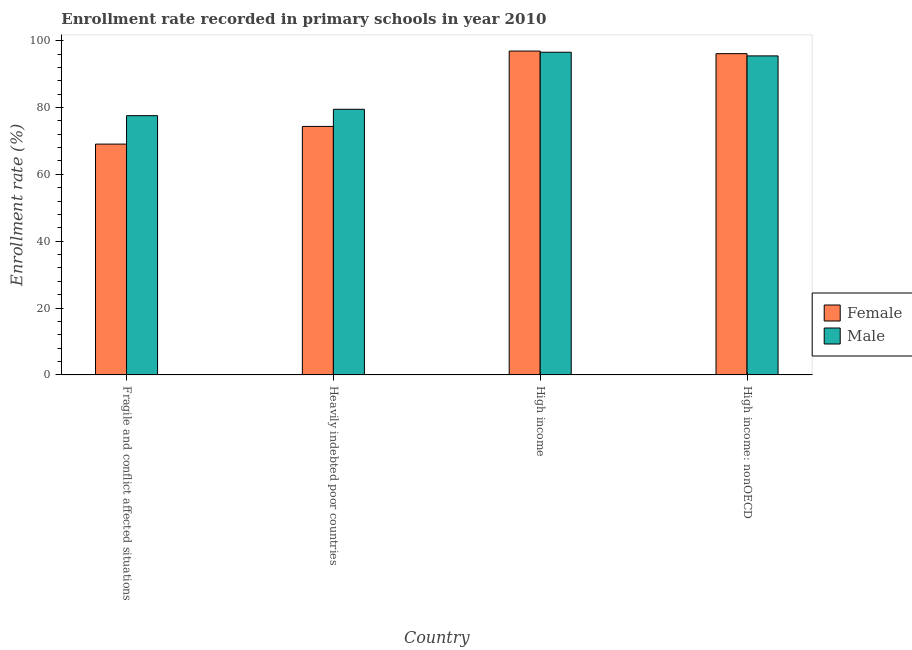How many different coloured bars are there?
Make the answer very short. 2. How many bars are there on the 2nd tick from the left?
Provide a short and direct response. 2. How many bars are there on the 1st tick from the right?
Give a very brief answer. 2. What is the label of the 4th group of bars from the left?
Provide a succinct answer. High income: nonOECD. What is the enrollment rate of female students in Fragile and conflict affected situations?
Your response must be concise. 69.05. Across all countries, what is the maximum enrollment rate of male students?
Make the answer very short. 96.54. Across all countries, what is the minimum enrollment rate of female students?
Provide a succinct answer. 69.05. In which country was the enrollment rate of male students maximum?
Provide a succinct answer. High income. In which country was the enrollment rate of female students minimum?
Your answer should be compact. Fragile and conflict affected situations. What is the total enrollment rate of male students in the graph?
Provide a succinct answer. 349. What is the difference between the enrollment rate of female students in Fragile and conflict affected situations and that in High income: nonOECD?
Make the answer very short. -27.06. What is the difference between the enrollment rate of female students in Heavily indebted poor countries and the enrollment rate of male students in Fragile and conflict affected situations?
Ensure brevity in your answer.  -3.22. What is the average enrollment rate of female students per country?
Keep it short and to the point. 84.1. What is the difference between the enrollment rate of female students and enrollment rate of male students in Heavily indebted poor countries?
Provide a short and direct response. -5.12. What is the ratio of the enrollment rate of male students in Heavily indebted poor countries to that in High income: nonOECD?
Provide a succinct answer. 0.83. Is the enrollment rate of male students in Fragile and conflict affected situations less than that in High income: nonOECD?
Provide a short and direct response. Yes. Is the difference between the enrollment rate of male students in Heavily indebted poor countries and High income greater than the difference between the enrollment rate of female students in Heavily indebted poor countries and High income?
Make the answer very short. Yes. What is the difference between the highest and the second highest enrollment rate of male students?
Offer a very short reply. 1.1. What is the difference between the highest and the lowest enrollment rate of male students?
Ensure brevity in your answer.  18.98. What does the 1st bar from the left in Fragile and conflict affected situations represents?
Your answer should be very brief. Female. Are all the bars in the graph horizontal?
Offer a very short reply. No. Are the values on the major ticks of Y-axis written in scientific E-notation?
Make the answer very short. No. Does the graph contain grids?
Offer a very short reply. No. What is the title of the graph?
Your answer should be very brief. Enrollment rate recorded in primary schools in year 2010. Does "RDB nonconcessional" appear as one of the legend labels in the graph?
Your answer should be compact. No. What is the label or title of the Y-axis?
Offer a terse response. Enrollment rate (%). What is the Enrollment rate (%) of Female in Fragile and conflict affected situations?
Make the answer very short. 69.05. What is the Enrollment rate (%) in Male in Fragile and conflict affected situations?
Your answer should be very brief. 77.56. What is the Enrollment rate (%) in Female in Heavily indebted poor countries?
Keep it short and to the point. 74.34. What is the Enrollment rate (%) of Male in Heavily indebted poor countries?
Offer a very short reply. 79.46. What is the Enrollment rate (%) of Female in High income?
Provide a succinct answer. 96.88. What is the Enrollment rate (%) in Male in High income?
Your answer should be compact. 96.54. What is the Enrollment rate (%) of Female in High income: nonOECD?
Your answer should be compact. 96.11. What is the Enrollment rate (%) in Male in High income: nonOECD?
Keep it short and to the point. 95.44. Across all countries, what is the maximum Enrollment rate (%) in Female?
Your response must be concise. 96.88. Across all countries, what is the maximum Enrollment rate (%) of Male?
Keep it short and to the point. 96.54. Across all countries, what is the minimum Enrollment rate (%) of Female?
Offer a terse response. 69.05. Across all countries, what is the minimum Enrollment rate (%) of Male?
Your answer should be compact. 77.56. What is the total Enrollment rate (%) in Female in the graph?
Provide a succinct answer. 336.39. What is the total Enrollment rate (%) of Male in the graph?
Make the answer very short. 349. What is the difference between the Enrollment rate (%) of Female in Fragile and conflict affected situations and that in Heavily indebted poor countries?
Make the answer very short. -5.29. What is the difference between the Enrollment rate (%) of Male in Fragile and conflict affected situations and that in Heavily indebted poor countries?
Your response must be concise. -1.9. What is the difference between the Enrollment rate (%) of Female in Fragile and conflict affected situations and that in High income?
Your response must be concise. -27.83. What is the difference between the Enrollment rate (%) in Male in Fragile and conflict affected situations and that in High income?
Keep it short and to the point. -18.98. What is the difference between the Enrollment rate (%) of Female in Fragile and conflict affected situations and that in High income: nonOECD?
Offer a terse response. -27.06. What is the difference between the Enrollment rate (%) in Male in Fragile and conflict affected situations and that in High income: nonOECD?
Your answer should be compact. -17.88. What is the difference between the Enrollment rate (%) of Female in Heavily indebted poor countries and that in High income?
Offer a very short reply. -22.54. What is the difference between the Enrollment rate (%) in Male in Heavily indebted poor countries and that in High income?
Keep it short and to the point. -17.07. What is the difference between the Enrollment rate (%) of Female in Heavily indebted poor countries and that in High income: nonOECD?
Offer a terse response. -21.77. What is the difference between the Enrollment rate (%) of Male in Heavily indebted poor countries and that in High income: nonOECD?
Ensure brevity in your answer.  -15.98. What is the difference between the Enrollment rate (%) of Female in High income and that in High income: nonOECD?
Your answer should be compact. 0.77. What is the difference between the Enrollment rate (%) in Male in High income and that in High income: nonOECD?
Provide a short and direct response. 1.1. What is the difference between the Enrollment rate (%) in Female in Fragile and conflict affected situations and the Enrollment rate (%) in Male in Heavily indebted poor countries?
Your response must be concise. -10.41. What is the difference between the Enrollment rate (%) of Female in Fragile and conflict affected situations and the Enrollment rate (%) of Male in High income?
Give a very brief answer. -27.49. What is the difference between the Enrollment rate (%) of Female in Fragile and conflict affected situations and the Enrollment rate (%) of Male in High income: nonOECD?
Provide a succinct answer. -26.39. What is the difference between the Enrollment rate (%) in Female in Heavily indebted poor countries and the Enrollment rate (%) in Male in High income?
Make the answer very short. -22.2. What is the difference between the Enrollment rate (%) of Female in Heavily indebted poor countries and the Enrollment rate (%) of Male in High income: nonOECD?
Keep it short and to the point. -21.1. What is the difference between the Enrollment rate (%) in Female in High income and the Enrollment rate (%) in Male in High income: nonOECD?
Offer a very short reply. 1.44. What is the average Enrollment rate (%) of Female per country?
Ensure brevity in your answer.  84.1. What is the average Enrollment rate (%) in Male per country?
Your response must be concise. 87.25. What is the difference between the Enrollment rate (%) of Female and Enrollment rate (%) of Male in Fragile and conflict affected situations?
Provide a succinct answer. -8.51. What is the difference between the Enrollment rate (%) in Female and Enrollment rate (%) in Male in Heavily indebted poor countries?
Your response must be concise. -5.12. What is the difference between the Enrollment rate (%) in Female and Enrollment rate (%) in Male in High income?
Offer a very short reply. 0.35. What is the difference between the Enrollment rate (%) in Female and Enrollment rate (%) in Male in High income: nonOECD?
Give a very brief answer. 0.67. What is the ratio of the Enrollment rate (%) in Female in Fragile and conflict affected situations to that in Heavily indebted poor countries?
Make the answer very short. 0.93. What is the ratio of the Enrollment rate (%) in Male in Fragile and conflict affected situations to that in Heavily indebted poor countries?
Your answer should be compact. 0.98. What is the ratio of the Enrollment rate (%) of Female in Fragile and conflict affected situations to that in High income?
Ensure brevity in your answer.  0.71. What is the ratio of the Enrollment rate (%) in Male in Fragile and conflict affected situations to that in High income?
Your answer should be compact. 0.8. What is the ratio of the Enrollment rate (%) of Female in Fragile and conflict affected situations to that in High income: nonOECD?
Your response must be concise. 0.72. What is the ratio of the Enrollment rate (%) of Male in Fragile and conflict affected situations to that in High income: nonOECD?
Provide a short and direct response. 0.81. What is the ratio of the Enrollment rate (%) of Female in Heavily indebted poor countries to that in High income?
Provide a short and direct response. 0.77. What is the ratio of the Enrollment rate (%) of Male in Heavily indebted poor countries to that in High income?
Ensure brevity in your answer.  0.82. What is the ratio of the Enrollment rate (%) in Female in Heavily indebted poor countries to that in High income: nonOECD?
Your response must be concise. 0.77. What is the ratio of the Enrollment rate (%) in Male in Heavily indebted poor countries to that in High income: nonOECD?
Offer a very short reply. 0.83. What is the ratio of the Enrollment rate (%) in Female in High income to that in High income: nonOECD?
Provide a short and direct response. 1.01. What is the ratio of the Enrollment rate (%) in Male in High income to that in High income: nonOECD?
Provide a succinct answer. 1.01. What is the difference between the highest and the second highest Enrollment rate (%) of Female?
Keep it short and to the point. 0.77. What is the difference between the highest and the second highest Enrollment rate (%) in Male?
Ensure brevity in your answer.  1.1. What is the difference between the highest and the lowest Enrollment rate (%) of Female?
Give a very brief answer. 27.83. What is the difference between the highest and the lowest Enrollment rate (%) of Male?
Give a very brief answer. 18.98. 